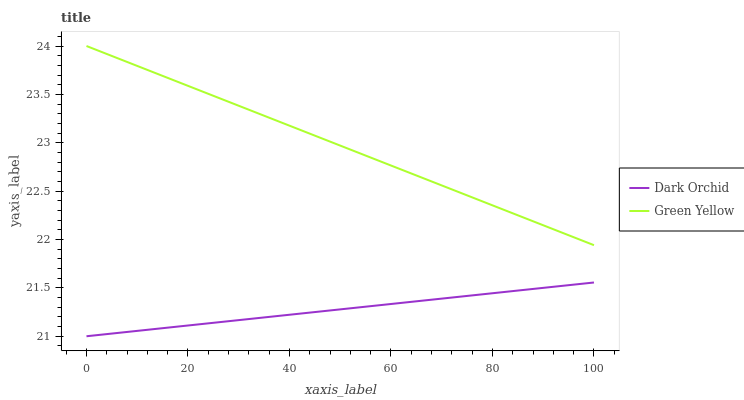Does Dark Orchid have the minimum area under the curve?
Answer yes or no. Yes. Does Green Yellow have the maximum area under the curve?
Answer yes or no. Yes. Does Dark Orchid have the maximum area under the curve?
Answer yes or no. No. Is Dark Orchid the smoothest?
Answer yes or no. Yes. Is Green Yellow the roughest?
Answer yes or no. Yes. Is Dark Orchid the roughest?
Answer yes or no. No. Does Dark Orchid have the lowest value?
Answer yes or no. Yes. Does Green Yellow have the highest value?
Answer yes or no. Yes. Does Dark Orchid have the highest value?
Answer yes or no. No. Is Dark Orchid less than Green Yellow?
Answer yes or no. Yes. Is Green Yellow greater than Dark Orchid?
Answer yes or no. Yes. Does Dark Orchid intersect Green Yellow?
Answer yes or no. No. 